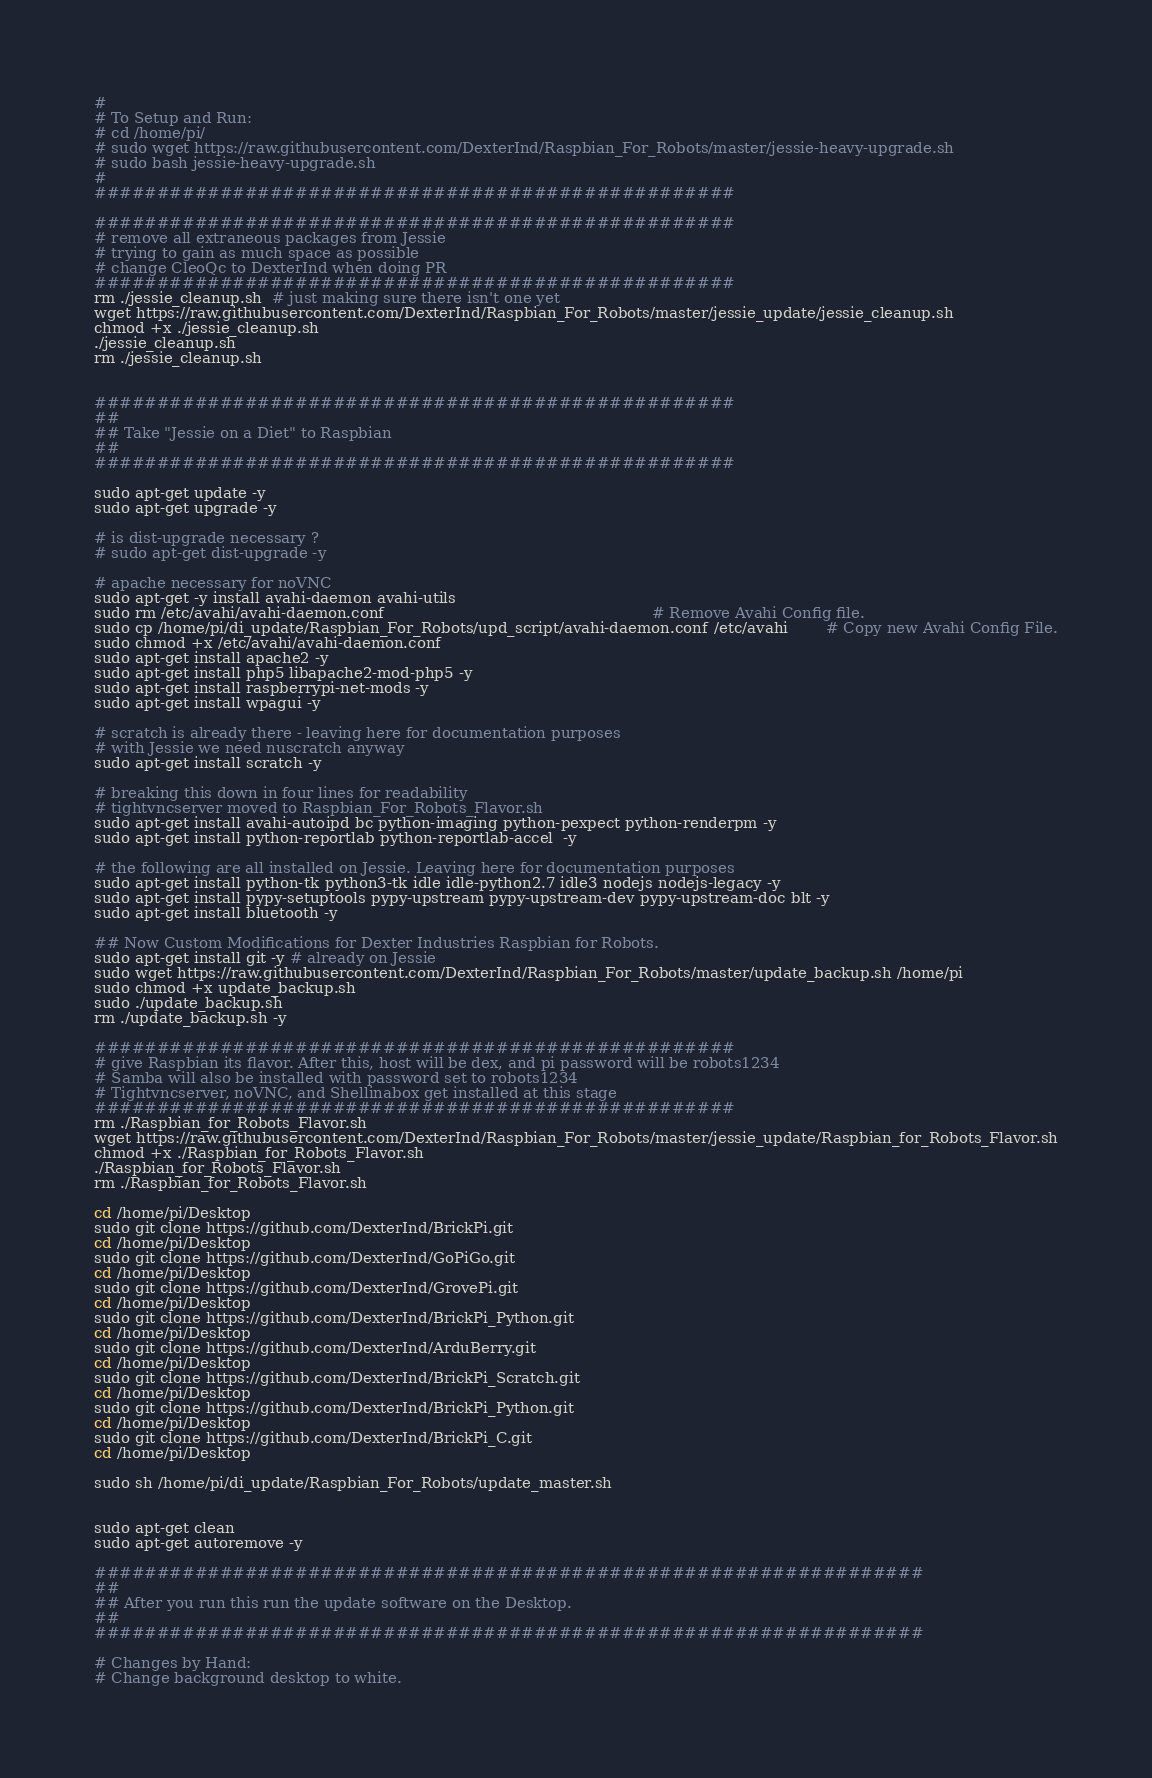<code> <loc_0><loc_0><loc_500><loc_500><_Bash_>#
# To Setup and Run:
# cd /home/pi/
# sudo wget https://raw.githubusercontent.com/DexterInd/Raspbian_For_Robots/master/jessie-heavy-upgrade.sh
# sudo bash jessie-heavy-upgrade.sh
#
###################################################

###################################################
# remove all extraneous packages from Jessie 
# trying to gain as much space as possible
# change CleoQc to DexterInd when doing PR
###################################################
rm ./jessie_cleanup.sh  # just making sure there isn't one yet
wget https://raw.githubusercontent.com/DexterInd/Raspbian_For_Robots/master/jessie_update/jessie_cleanup.sh
chmod +x ./jessie_cleanup.sh
./jessie_cleanup.sh
rm ./jessie_cleanup.sh


###################################################
##
## Take "Jessie on a Diet" to Raspbian
##
###################################################

sudo apt-get update -y
sudo apt-get upgrade -y

# is dist-upgrade necessary ? 
# sudo apt-get dist-upgrade -y

# apache necessary for noVNC
sudo apt-get -y install avahi-daemon avahi-utils
sudo rm /etc/avahi/avahi-daemon.conf 														# Remove Avahi Config file.
sudo cp /home/pi/di_update/Raspbian_For_Robots/upd_script/avahi-daemon.conf /etc/avahi 		# Copy new Avahi Config File.
sudo chmod +x /etc/avahi/avahi-daemon.conf 
sudo apt-get install apache2 -y
sudo apt-get install php5 libapache2-mod-php5 -y
sudo apt-get install raspberrypi-net-mods -y
sudo apt-get install wpagui -y

# scratch is already there - leaving here for documentation purposes
# with Jessie we need nuscratch anyway
sudo apt-get install scratch -y

# breaking this down in four lines for readability
# tightvncserver moved to Raspbian_For_Robots_Flavor.sh
sudo apt-get install avahi-autoipd bc python-imaging python-pexpect python-renderpm -y
sudo apt-get install python-reportlab python-reportlab-accel  -y

# the following are all installed on Jessie. Leaving here for documentation purposes
sudo apt-get install python-tk python3-tk idle idle-python2.7 idle3 nodejs nodejs-legacy -y
sudo apt-get install pypy-setuptools pypy-upstream pypy-upstream-dev pypy-upstream-doc blt -y
sudo apt-get install bluetooth -y

## Now Custom Modifications for Dexter Industries Raspbian for Robots.  
sudo apt-get install git -y # already on Jessie
sudo wget https://raw.githubusercontent.com/DexterInd/Raspbian_For_Robots/master/update_backup.sh /home/pi
sudo chmod +x update_backup.sh
sudo ./update_backup.sh
rm ./update_backup.sh -y

###################################################
# give Raspbian its flavor. After this, host will be dex, and pi password will be robots1234
# Samba will also be installed with password set to robots1234
# Tightvncserver, noVNC, and Shellinabox get installed at this stage
###################################################
rm ./Raspbian_for_Robots_Flavor.sh
wget https://raw.githubusercontent.com/DexterInd/Raspbian_For_Robots/master/jessie_update/Raspbian_for_Robots_Flavor.sh
chmod +x ./Raspbian_for_Robots_Flavor.sh
./Raspbian_for_Robots_Flavor.sh
rm ./Raspbian_for_Robots_Flavor.sh

cd /home/pi/Desktop
sudo git clone https://github.com/DexterInd/BrickPi.git
cd /home/pi/Desktop
sudo git clone https://github.com/DexterInd/GoPiGo.git
cd /home/pi/Desktop
sudo git clone https://github.com/DexterInd/GrovePi.git
cd /home/pi/Desktop
sudo git clone https://github.com/DexterInd/BrickPi_Python.git
cd /home/pi/Desktop
sudo git clone https://github.com/DexterInd/ArduBerry.git
cd /home/pi/Desktop
sudo git clone https://github.com/DexterInd/BrickPi_Scratch.git
cd /home/pi/Desktop
sudo git clone https://github.com/DexterInd/BrickPi_Python.git
cd /home/pi/Desktop
sudo git clone https://github.com/DexterInd/BrickPi_C.git
cd /home/pi/Desktop

sudo sh /home/pi/di_update/Raspbian_For_Robots/update_master.sh


sudo apt-get clean
sudo apt-get autoremove -y 

##################################################################
##
## After you run this run the update software on the Desktop.
##
##################################################################

# Changes by Hand:
# Change background desktop to white.
</code> 